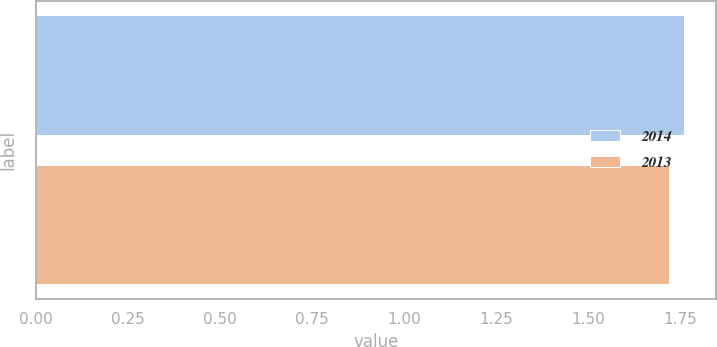<chart> <loc_0><loc_0><loc_500><loc_500><bar_chart><fcel>2014<fcel>2013<nl><fcel>1.76<fcel>1.72<nl></chart> 